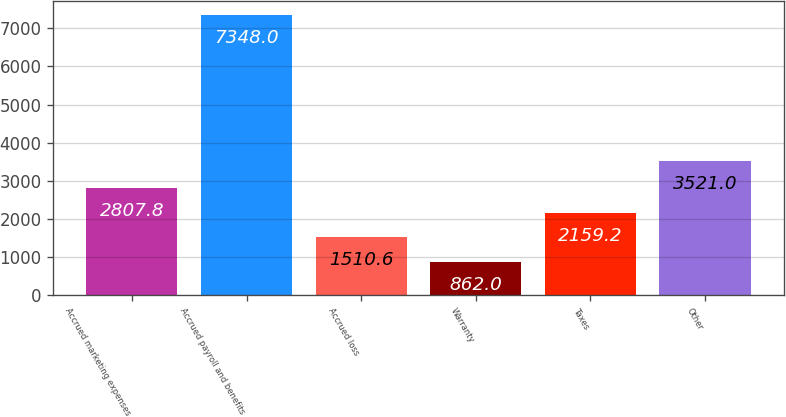<chart> <loc_0><loc_0><loc_500><loc_500><bar_chart><fcel>Accrued marketing expenses<fcel>Accrued payroll and benefits<fcel>Accrued loss<fcel>Warranty<fcel>Taxes<fcel>Other<nl><fcel>2807.8<fcel>7348<fcel>1510.6<fcel>862<fcel>2159.2<fcel>3521<nl></chart> 